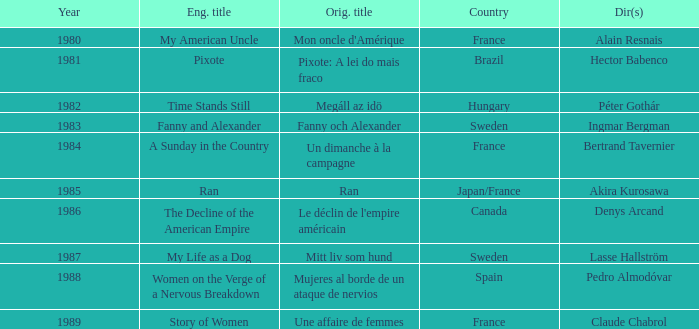What's the English Title of Fanny Och Alexander? Fanny and Alexander. Would you be able to parse every entry in this table? {'header': ['Year', 'Eng. title', 'Orig. title', 'Country', 'Dir(s)'], 'rows': [['1980', 'My American Uncle', "Mon oncle d'Amérique", 'France', 'Alain Resnais'], ['1981', 'Pixote', 'Pixote: A lei do mais fraco', 'Brazil', 'Hector Babenco'], ['1982', 'Time Stands Still', 'Megáll az idö', 'Hungary', 'Péter Gothár'], ['1983', 'Fanny and Alexander', 'Fanny och Alexander', 'Sweden', 'Ingmar Bergman'], ['1984', 'A Sunday in the Country', 'Un dimanche à la campagne', 'France', 'Bertrand Tavernier'], ['1985', 'Ran', 'Ran', 'Japan/France', 'Akira Kurosawa'], ['1986', 'The Decline of the American Empire', "Le déclin de l'empire américain", 'Canada', 'Denys Arcand'], ['1987', 'My Life as a Dog', 'Mitt liv som hund', 'Sweden', 'Lasse Hallström'], ['1988', 'Women on the Verge of a Nervous Breakdown', 'Mujeres al borde de un ataque de nervios', 'Spain', 'Pedro Almodóvar'], ['1989', 'Story of Women', 'Une affaire de femmes', 'France', 'Claude Chabrol']]} 